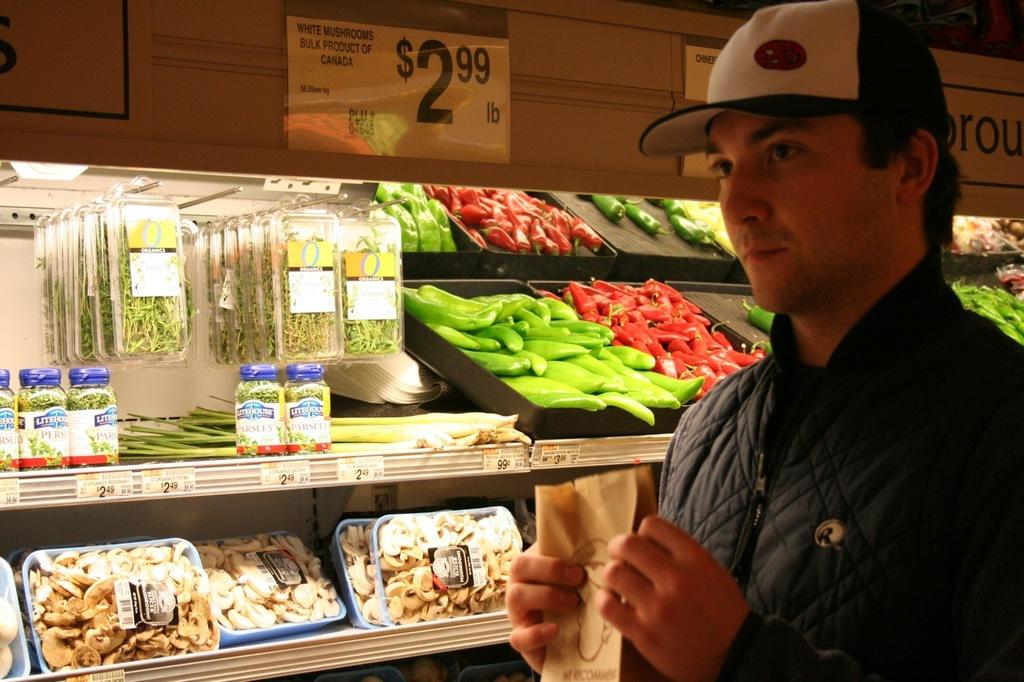What is the main subject of the image? There is a man in the image. What is the man holding in the image? The man is holding a cover and wire cap. What type of food items can be seen in the image? There are vegetables in the image. What type of storage containers are present in the image? There are boxes and jars in the image. What can be seen on the racks in the image? There are objects and boards on racks in the image. How many planes can be seen flying in the image? There are no planes visible in the image. What type of plastic material is used to make the boundary in the image? There is no plastic material or boundary present in the image. 